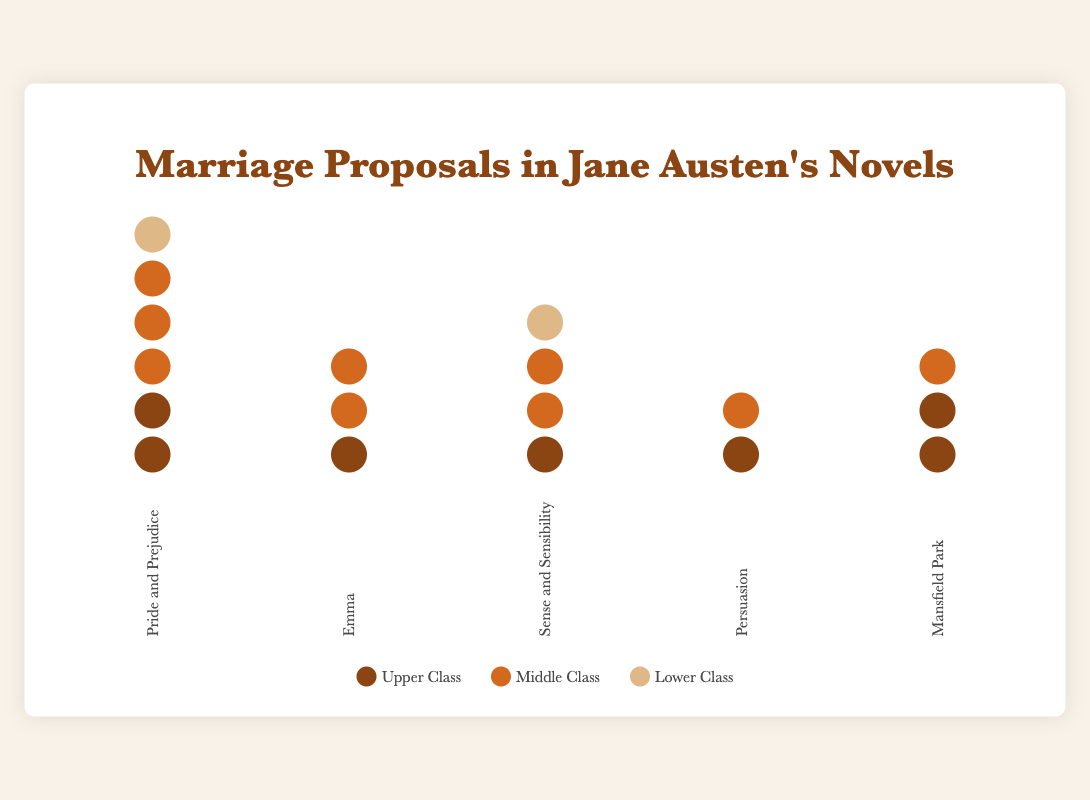How many marriage proposals are there in "Pride and Prejudice"? There are 2 proposals by Upper Class, 3 by Middle Class, and 1 by Lower Class in "Pride and Prejudice". Summing these values, we get 2 + 3 + 1 = 6.
Answer: 6 Which novel has the highest number of marriage proposals from the Upper Class? "Pride and Prejudice" and "Mansfield Park" both have 2 proposals from the Upper Class. No other novel has more than 2 proposals from the Upper Class.
Answer: Pride and Prejudice, Mansfield Park How many Lower Class proposals are there in total across all novels? For each novel: "Pride and Prejudice" has 1, "Emma" has 0, "Sense and Sensibility" has 1, "Persuasion" has 0, and "Mansfield Park" has 0. Summing these, we get 1 + 0 + 1 + 0 + 0 = 2.
Answer: 2 Which novel has the least number of marriage proposals? By counting the total proposals for each novel, we find "Persuasion" has the least, with 2 proposals in total.
Answer: Persuasion How do the number of Middle Class proposals in "Emma" compare to those in "Sense and Sensibility"? "Emma" has 2 proposals from Middle Class, and "Sense and Sensibility" also has 2 proposals from Middle Class. They are equal.
Answer: Equal What is the average number of marriage proposals per novel in the dataset? Adding total proposals per novel: Pride and Prejudice (6), Emma (3), Sense and Sensibility (4), Persuasion (2), and Mansfield Park (3). Summing these gives 6 + 3 + 4 + 2 + 3 = 18. Dividing by the number of novels (5), the average is 18/5 = 3.6.
Answer: 3.6 Which social class has the highest number of marriage proposals in "Sense and Sensibility"? In "Sense and Sensibility", Upper Class has 1, Middle Class has 2, and Lower Class has 1. The Middle Class has the highest number.
Answer: Middle Class How many total proposals are there from the Upper Class across all novels? Summing the Upper Class proposals for each novel: Pride and Prejudice (2), Emma (1), Sense and Sensibility (1), Persuasion (1), and Mansfield Park (2). The total is 2 + 1 + 1 + 1 + 2 = 7.
Answer: 7 Which novel has the most balanced distribution of marriage proposals across different social classes? Looking at the distribution across classes: "Pride and Prejudice" (2 Upper, 3 Middle, 1 Lower), "Emma" (1 Upper, 2 Middle, 0 Lower), "Sense and Sensibility" (1 Upper, 2 Middle, 1 Lower), "Persuasion" (1 Upper, 1 Middle, 0 Lower), "Mansfield Park" (2 Upper, 1 Middle, 0 Lower). "Sense and Sensibility" appears to be the most balanced with representation in all classes.
Answer: Sense and Sensibility What percentage of total proposals in "Pride and Prejudice" are from the Middle Class? "Pride and Prejudice" has 6 total proposals with 3 from the Middle Class. The percentage is (3/6) * 100 = 50%.
Answer: 50% 